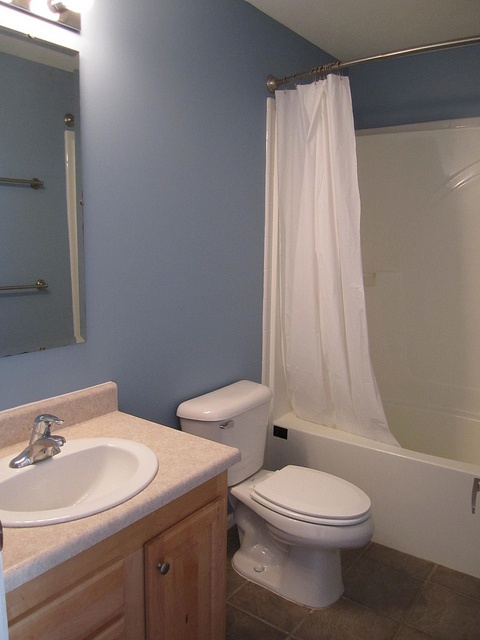Describe the objects in this image and their specific colors. I can see toilet in lightgray, gray, tan, and darkgray tones and sink in lightgray and darkgray tones in this image. 